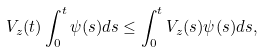Convert formula to latex. <formula><loc_0><loc_0><loc_500><loc_500>V _ { z } ( t ) \int _ { 0 } ^ { t } \psi ( s ) d s \leq \int _ { 0 } ^ { t } V _ { z } ( s ) \psi ( s ) d s ,</formula> 